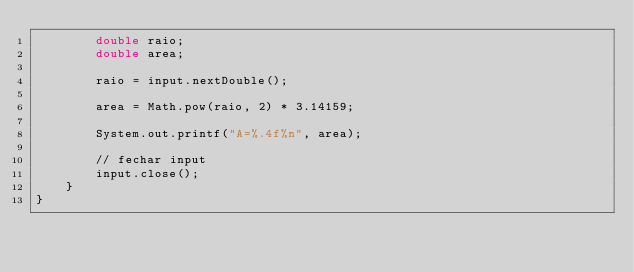<code> <loc_0><loc_0><loc_500><loc_500><_Java_>        double raio;
        double area;

        raio = input.nextDouble();

        area = Math.pow(raio, 2) * 3.14159;

        System.out.printf("A=%.4f%n", area);

        // fechar input
        input.close();
    }
}
</code> 